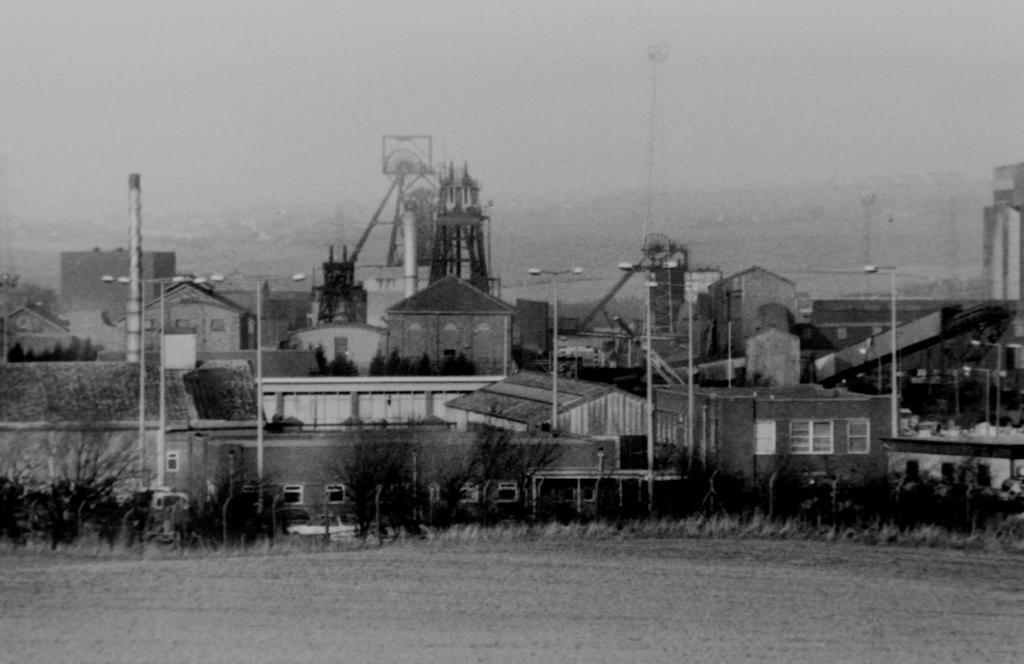Please provide a concise description of this image. In the picture we can see the surface with trees, poles, houses, buildings, and the sky. 